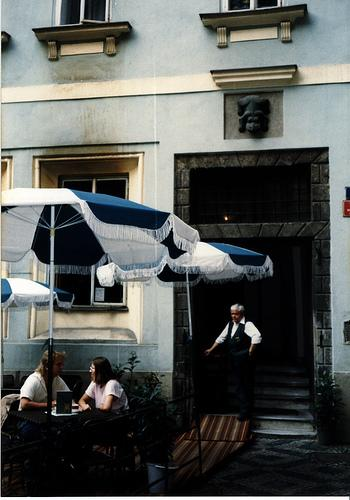What is the main thing happening in the image related to people? Several people are either standing or seated in and around a building, with some interacting near doorways, and others seated at tables. Identify the person with most characteristics mentioned in the image description. The older man wearing a formal uniform, silver hair, white collared shirt, black vest, black pants, and black shoes. What is the color combination on the umbrella in the image? The umbrella has white fringe, a blue panel, and a white panel, supported by metal poles. Analyze the object interaction in the image, focusing on seating arrangements. Two people are seated at a table, with additional single-person seating at different positions, for a total of three individuals seated. How many windows and doorways are described in this image? Provide the count for each. Doorways: 3 Count the total number of objects related to the umbrella in the image. Five objects: white fringe, blue panel, white panel, metal pole, and pole supporting the open umbrella. What type of rug is mentioned in the image description? A brown rug with stripes. How many people are seated at a table in the image? Please provide a number. Three people. 